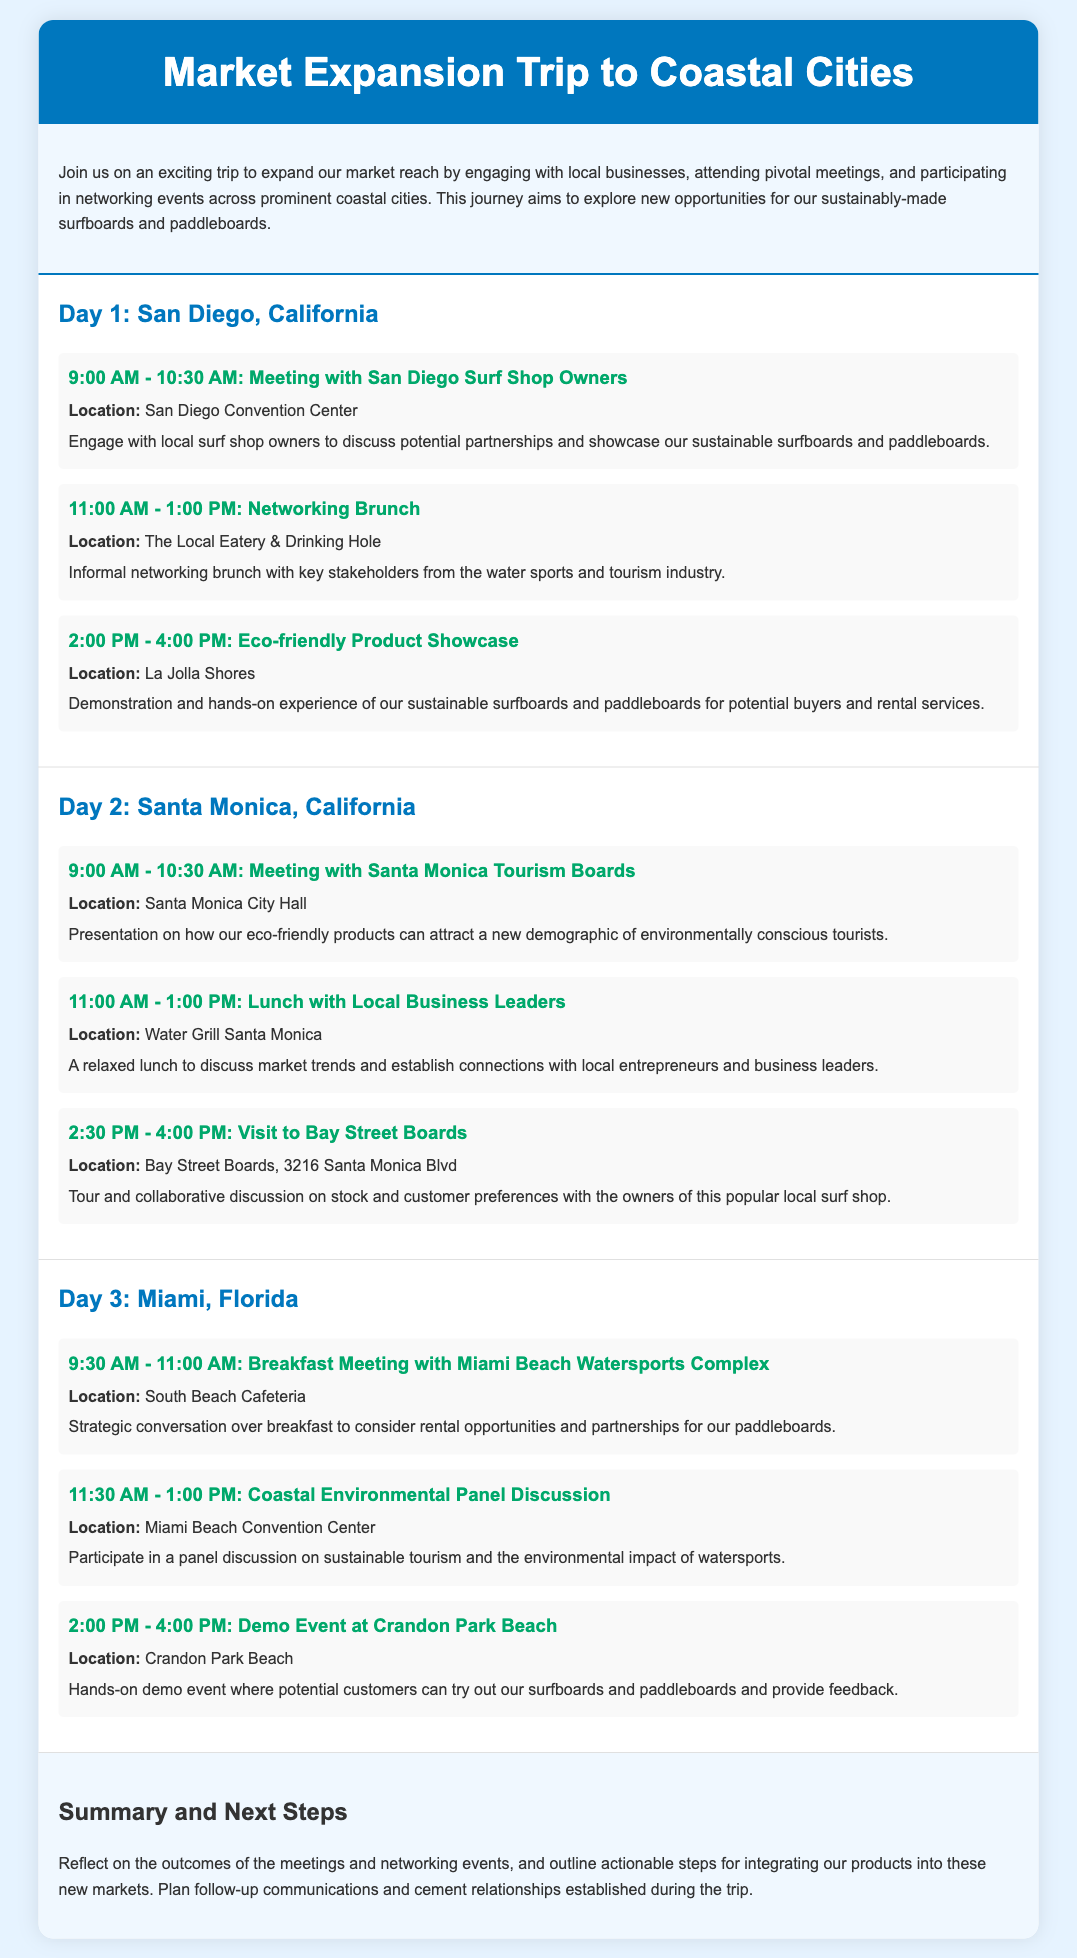What city is the first stop of the trip? The first destination mentioned in the itinerary is San Diego, California.
Answer: San Diego, California What activity is scheduled for 11:00 AM on Day 1? The activity planned for that time is a networking brunch with key stakeholders from the water sports and tourism industry.
Answer: Networking Brunch Where is the Eco-friendly Product Showcase located? The location of the Eco-friendly Product Showcase is La Jolla Shores.
Answer: La Jolla Shores What time does the meeting with Santa Monica Tourism Boards start? The meeting is scheduled to start at 9:00 AM on Day 2.
Answer: 9:00 AM Which event on Day 3 includes a panel discussion? The Coastal Environmental Panel Discussion is the event that includes a panel discussion.
Answer: Coastal Environmental Panel Discussion What is the purpose of visiting Bay Street Boards? The visit aims for a tour and collaborative discussion on stock and customer preferences.
Answer: Collaborative discussion How many days is the market expansion trip? The trip spans three days based on the structured itinerary presented.
Answer: Three days What type of product is featured in the demo event at Crandon Park Beach? The demo event features paddleboards and surfboards that potential customers can try out.
Answer: Paddleboards and surfboards 